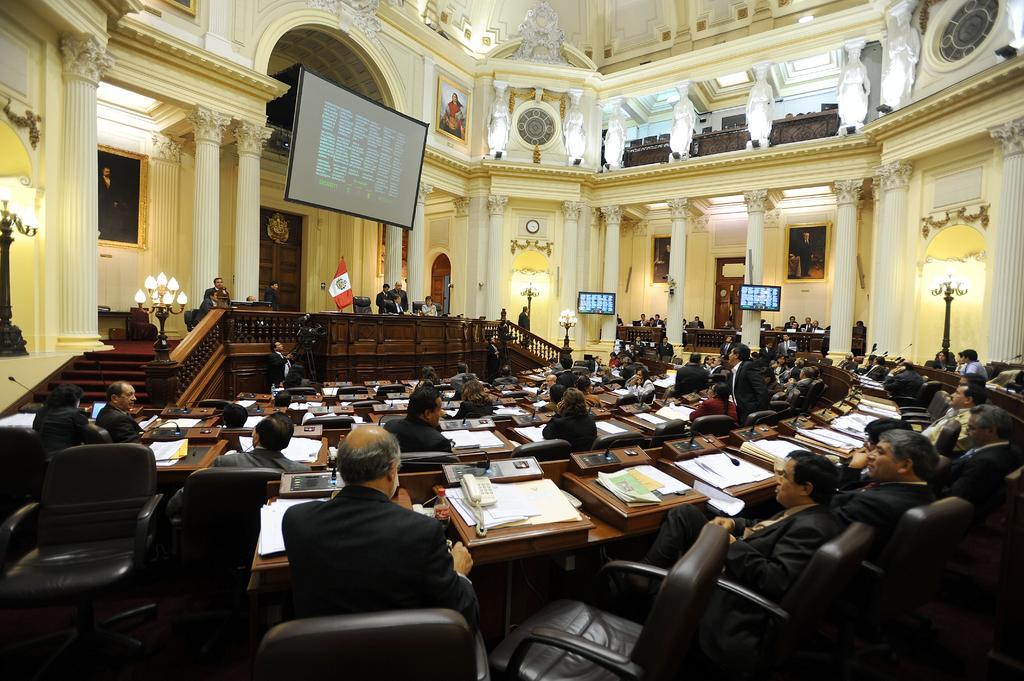How would you summarize this image in a sentence or two? In this image there are group of people sitting on the chair. On the table there is telephone,papers,bottle and a mic. At the background we can see a flag and a screen. 